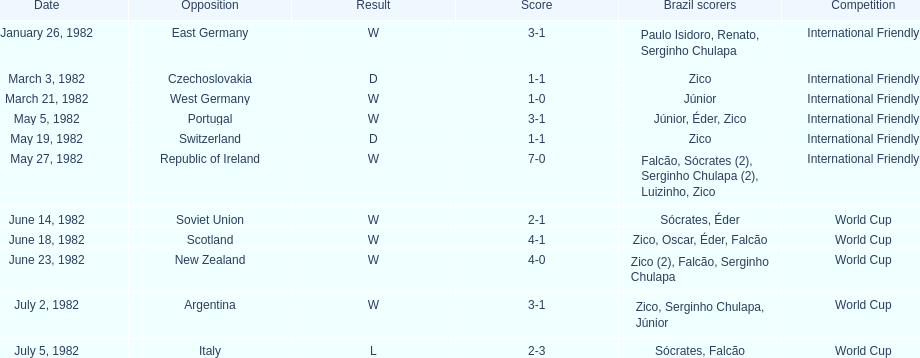Could you parse the entire table? {'header': ['Date', 'Opposition', 'Result', 'Score', 'Brazil scorers', 'Competition'], 'rows': [['January 26, 1982', 'East Germany', 'W', '3-1', 'Paulo Isidoro, Renato, Serginho Chulapa', 'International Friendly'], ['March 3, 1982', 'Czechoslovakia', 'D', '1-1', 'Zico', 'International Friendly'], ['March 21, 1982', 'West Germany', 'W', '1-0', 'Júnior', 'International Friendly'], ['May 5, 1982', 'Portugal', 'W', '3-1', 'Júnior, Éder, Zico', 'International Friendly'], ['May 19, 1982', 'Switzerland', 'D', '1-1', 'Zico', 'International Friendly'], ['May 27, 1982', 'Republic of Ireland', 'W', '7-0', 'Falcão, Sócrates (2), Serginho Chulapa (2), Luizinho, Zico', 'International Friendly'], ['June 14, 1982', 'Soviet Union', 'W', '2-1', 'Sócrates, Éder', 'World Cup'], ['June 18, 1982', 'Scotland', 'W', '4-1', 'Zico, Oscar, Éder, Falcão', 'World Cup'], ['June 23, 1982', 'New Zealand', 'W', '4-0', 'Zico (2), Falcão, Serginho Chulapa', 'World Cup'], ['July 2, 1982', 'Argentina', 'W', '3-1', 'Zico, Serginho Chulapa, Júnior', 'World Cup'], ['July 5, 1982', 'Italy', 'L', '2-3', 'Sócrates, Falcão', 'World Cup']]} During the 1982 season, what was the number of encounters between brazil and west germany? 1. 